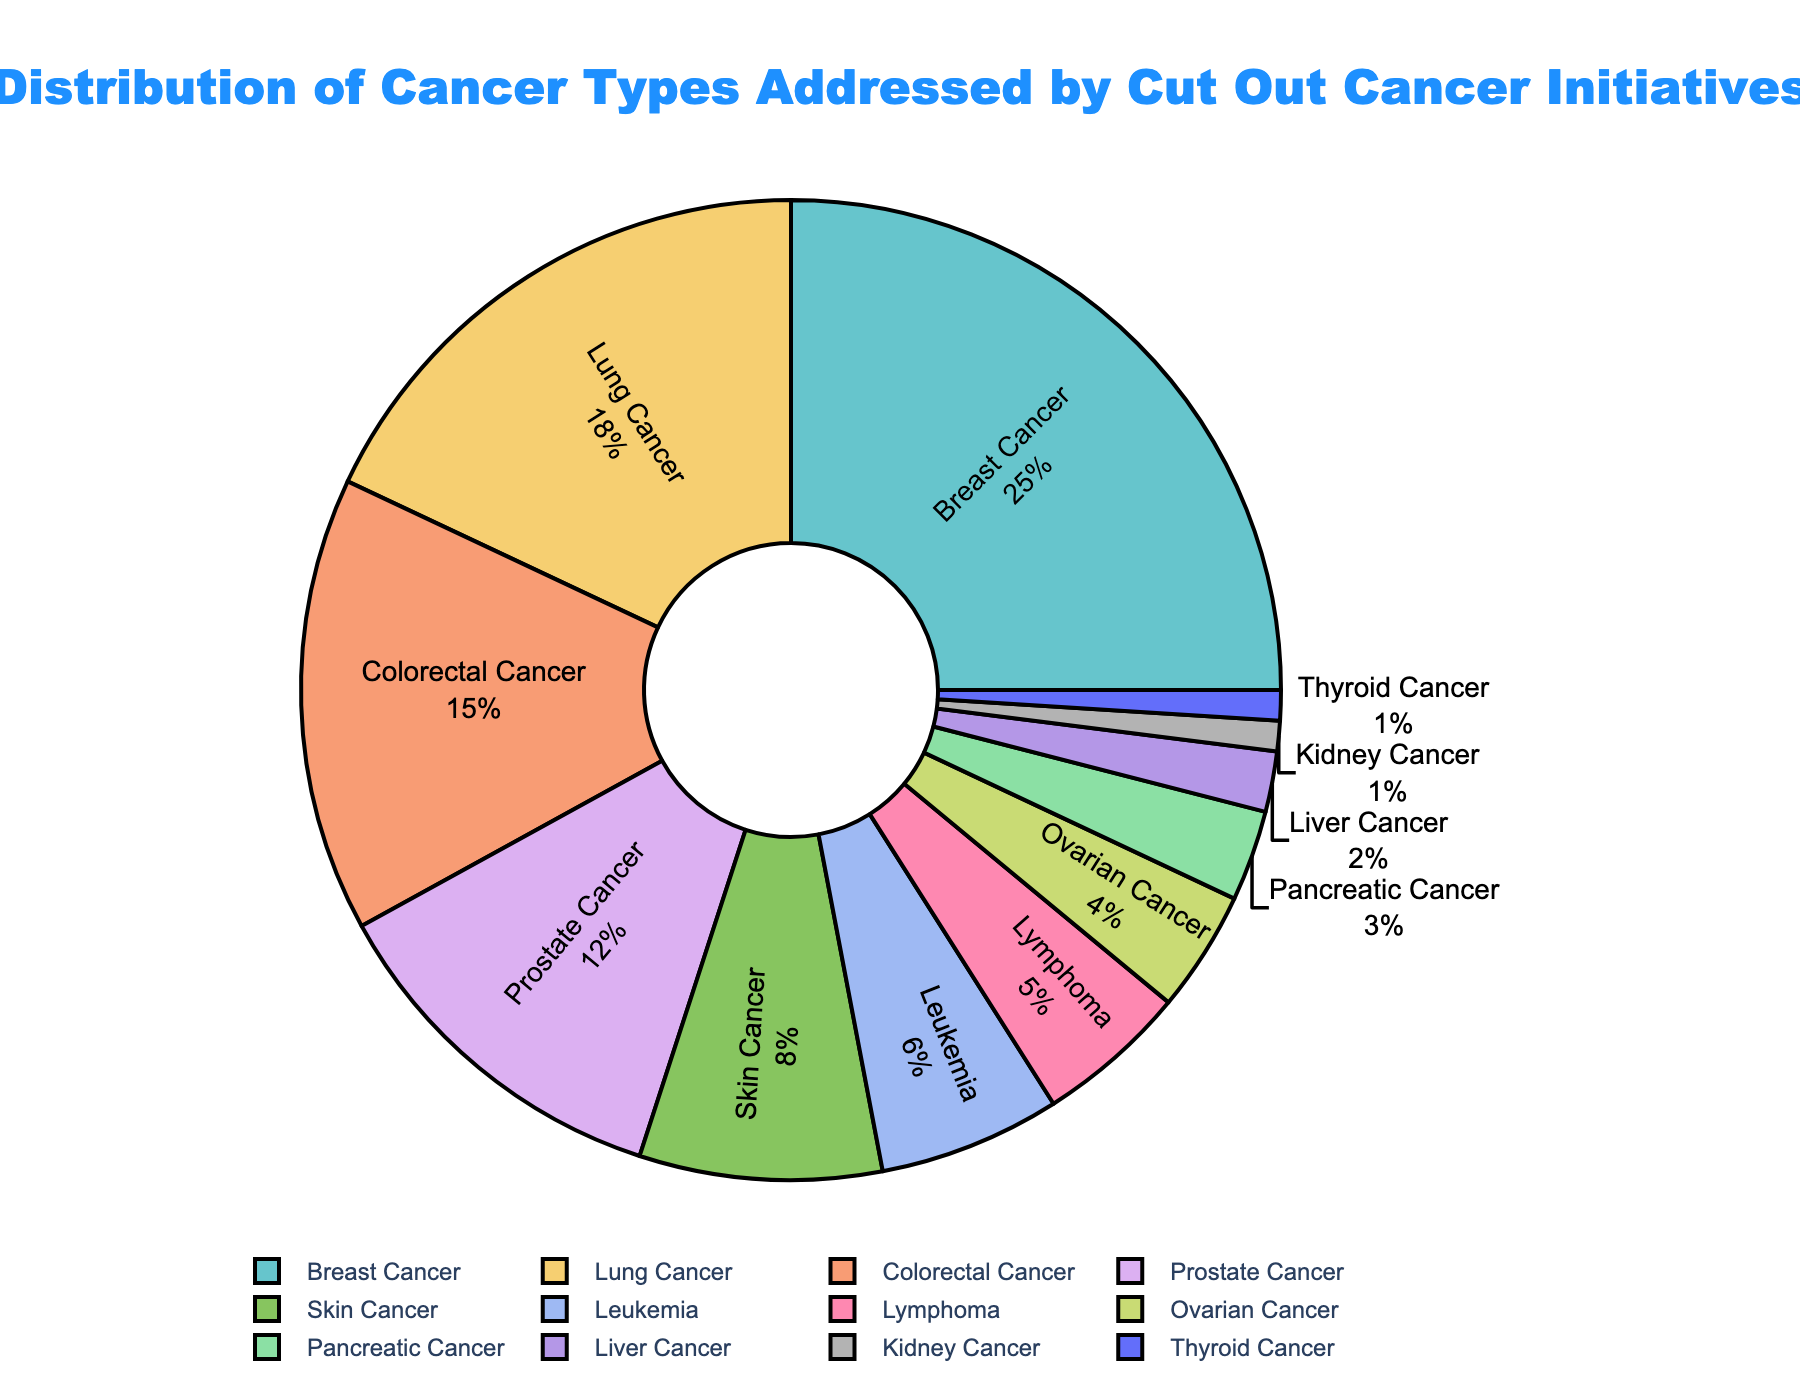How many types of cancer are addressed by Cut Out Cancer initiatives? To find the number of different cancer types addressed, count the unique categories listed in the pie chart. Each category corresponds to a segment of the chart.
Answer: 12 Which cancer type is addressed the most by the Cut Out Cancer initiatives? Identify the segment of the pie chart with the largest percentage. In this case, it is the segment labeled "Breast Cancer" with 25%.
Answer: Breast Cancer What is the combined percentage of cancer types addressed by Cut Out Cancer initiatives for Lung Cancer, Colorectal Cancer, and Prostate Cancer? Add the percentages for Lung Cancer (18%), Colorectal Cancer (15%), and Prostate Cancer (12%): \( 18 + 15 + 12 = 45 \).
Answer: 45% Is the percentage of initiatives addressing Breast Cancer greater than the combined percentage for Leukemia and Lymphoma? The percentage for Breast Cancer is 25%. The combined percentage for Leukemia (6%) and Lymphoma (5%) is \( 6 + 5 = 11 \%). Comparing 25% and 11%, 25% is greater.
Answer: Yes What is the difference in the percentage of initiatives between the cancer type addressed the most and the one addressed the least? The most-addressed cancer type is Breast Cancer at 25%, and the least-addressed types are Kidney Cancer and Thyroid Cancer at 1%. The difference is \( 25 - 1 = 24 \).
Answer: 24% How many cancer types have an initiative percentage of less than or equal to 5%? Count the cancer types with percentages of 5% or below: Leukemia (6%), Lymphoma (5%), Ovarian Cancer (4%), Pancreatic Cancer (3%), Liver Cancer (2%), Kidney Cancer (1%), Thyroid Cancer (1%).
Answer: 6 What percentage of cancer types are addressed by initiatives that have less than 10% each? Sum the percentages for types with less than 10%: Skin Cancer (8%), Leukemia (6%), Lymphoma (5%), Ovarian Cancer (4%), Pancreatic Cancer (3%), Liver Cancer (2%), Kidney Cancer (1%), Thyroid Cancer (1%). The total is \( 8 + 6 + 5 + 4 + 3 + 2 + 1 + 1 = 30 \).
Answer: 30% Which visual attribute makes it clear that Breast Cancer initiatives are the most significant part of the chart? The segment for Breast Cancer is the largest, occupying the biggest portion of the circle, and the percentage displayed is the highest at 25%.
Answer: Largest segment and highest percentage What is the percentage difference between Skin Cancer initiatives and Prostate Cancer initiatives? Prostate Cancer has a percentage of 12%, and Skin Cancer has 8%. The difference is \( 12 - 8 = 4 \).
Answer: 4% Compare the initiative percentage of Ovarian Cancer and Pancreatic Cancer. Which one is higher, and by how much? Ovarian Cancer has a percentage of 4%, while Pancreatic Cancer has 3%. The difference is \( 4 - 3 = 1 \). Ovarian Cancer's percentage is higher by 1%.
Answer: Ovarian Cancer by 1% 